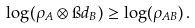Convert formula to latex. <formula><loc_0><loc_0><loc_500><loc_500>\log ( \rho _ { A } \otimes \i d _ { B } ) \geq \log ( \rho _ { A B } ) \, .</formula> 